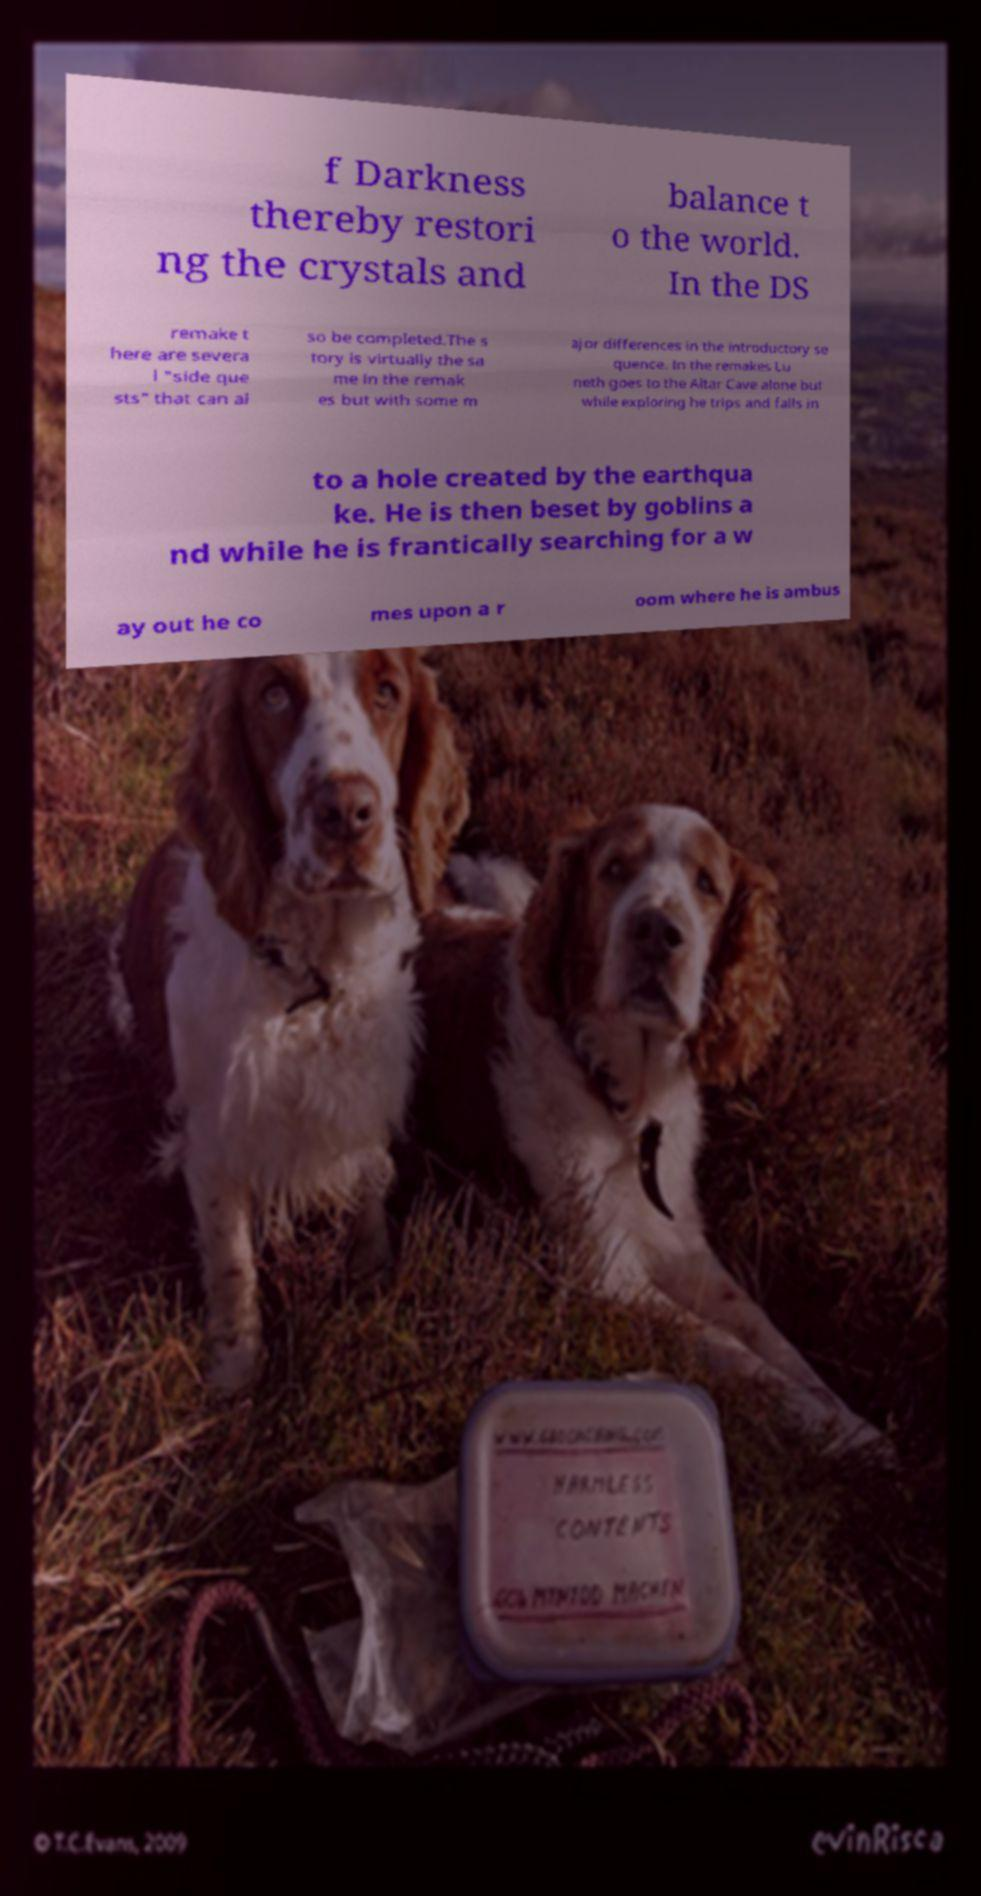For documentation purposes, I need the text within this image transcribed. Could you provide that? f Darkness thereby restori ng the crystals and balance t o the world. In the DS remake t here are severa l "side que sts" that can al so be completed.The s tory is virtually the sa me in the remak es but with some m ajor differences in the introductory se quence. In the remakes Lu neth goes to the Altar Cave alone but while exploring he trips and falls in to a hole created by the earthqua ke. He is then beset by goblins a nd while he is frantically searching for a w ay out he co mes upon a r oom where he is ambus 